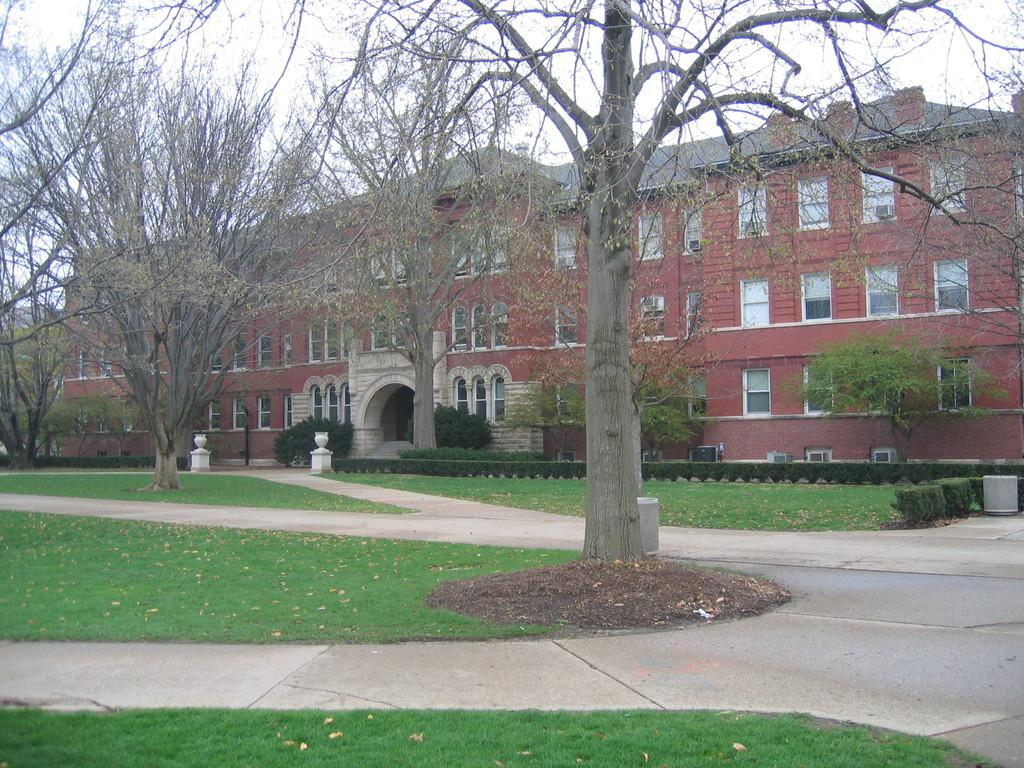What is the main structure in the image? There is a big building in the image. What color is the building? The building is one color. What type of vegetation can be seen in the image? There are many trees, plants, and bushes in the image. What is the ground covered with in the image? There is green grass on the ground. Are there any architectural features on the building? Yes, there are some pillars on the building. What else can be seen in the image besides the building and vegetation? There are roads in the image. What is visible at the top of the image? The sky is visible at the top of the image. What is the price of the science experiment being conducted in the image? There is no science experiment or price mentioned in the image; it primarily features a big building, vegetation, and roads. 